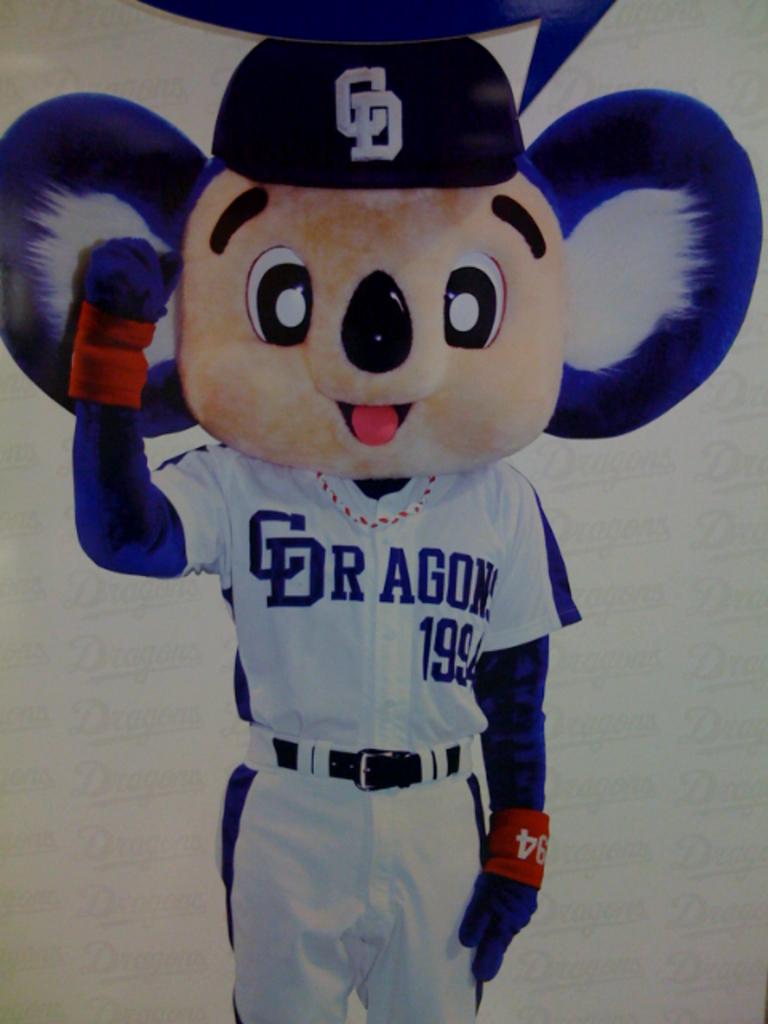What team does the koala play for?
Give a very brief answer. Dragons. What is his jersey number?
Offer a terse response. 199. 